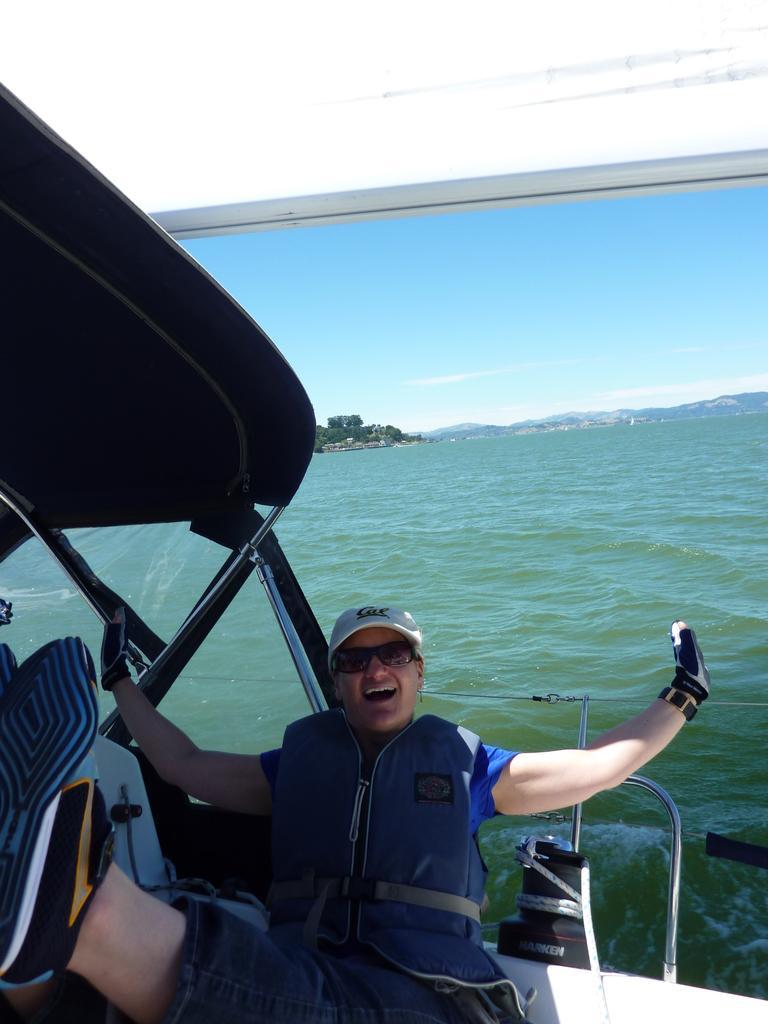Could you give a brief overview of what you see in this image? In the foreground I can see a person in the boat. In the background I can see water, trees and mountains. On the top I can see the sky. This image is taken during a day in the ocean. 